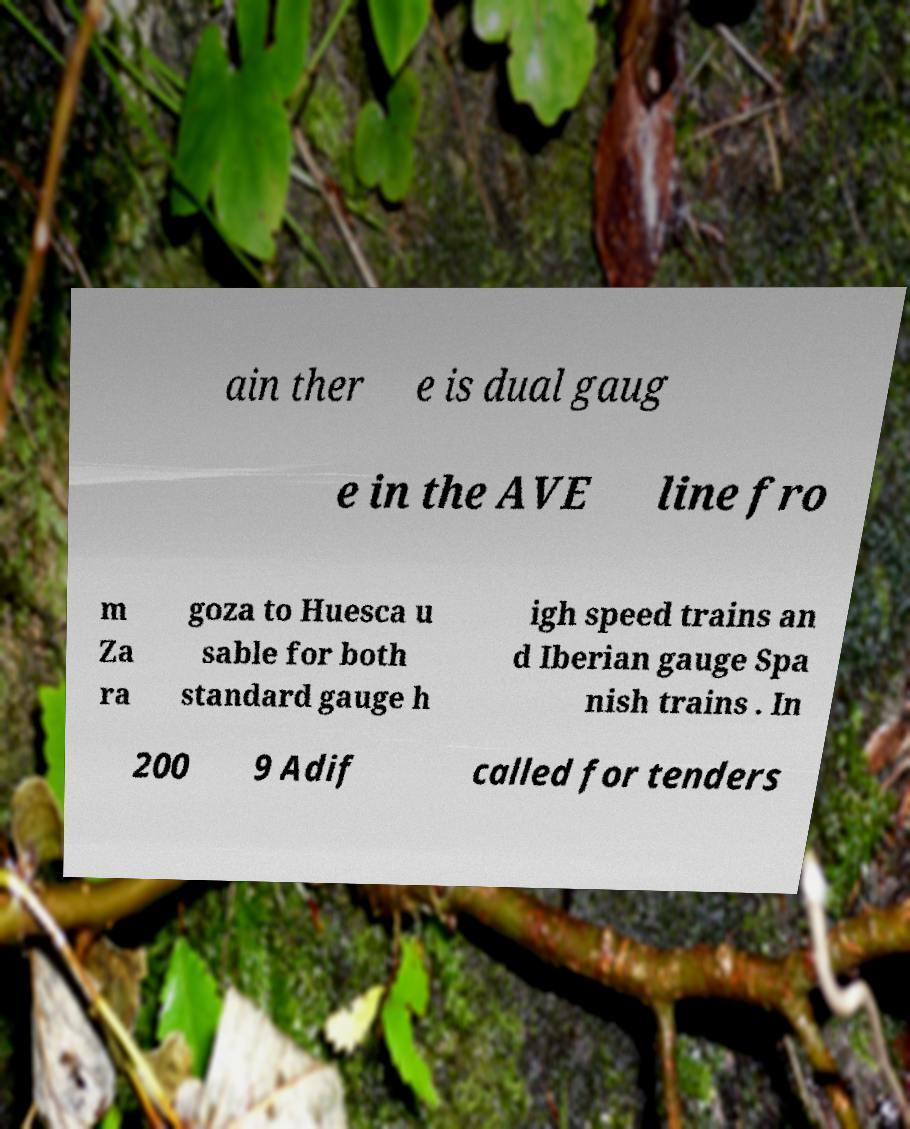Can you read and provide the text displayed in the image?This photo seems to have some interesting text. Can you extract and type it out for me? ain ther e is dual gaug e in the AVE line fro m Za ra goza to Huesca u sable for both standard gauge h igh speed trains an d Iberian gauge Spa nish trains . In 200 9 Adif called for tenders 